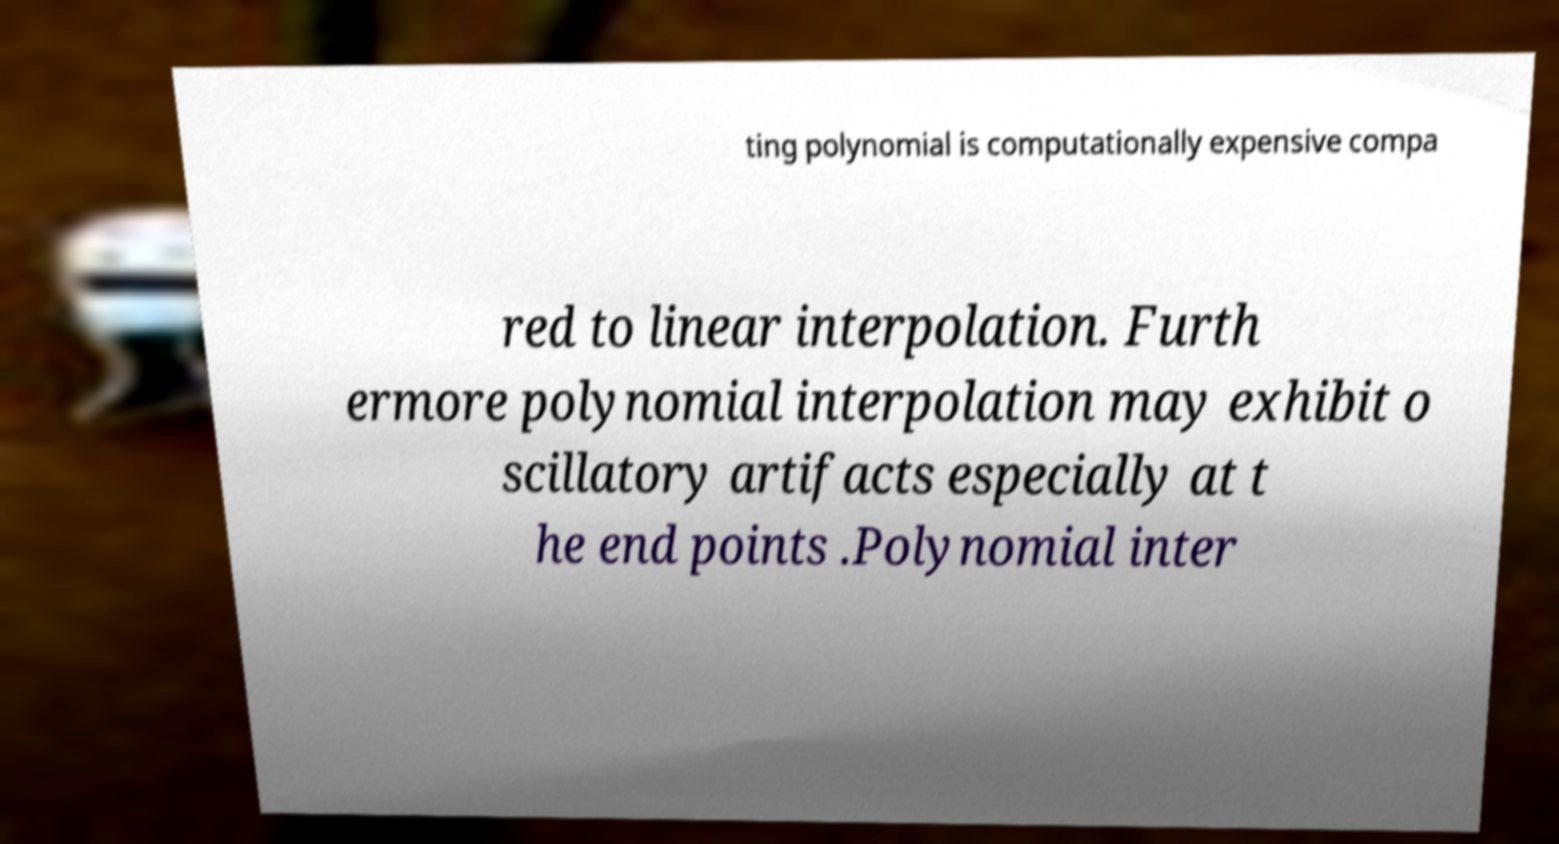Please read and relay the text visible in this image. What does it say? ting polynomial is computationally expensive compa red to linear interpolation. Furth ermore polynomial interpolation may exhibit o scillatory artifacts especially at t he end points .Polynomial inter 